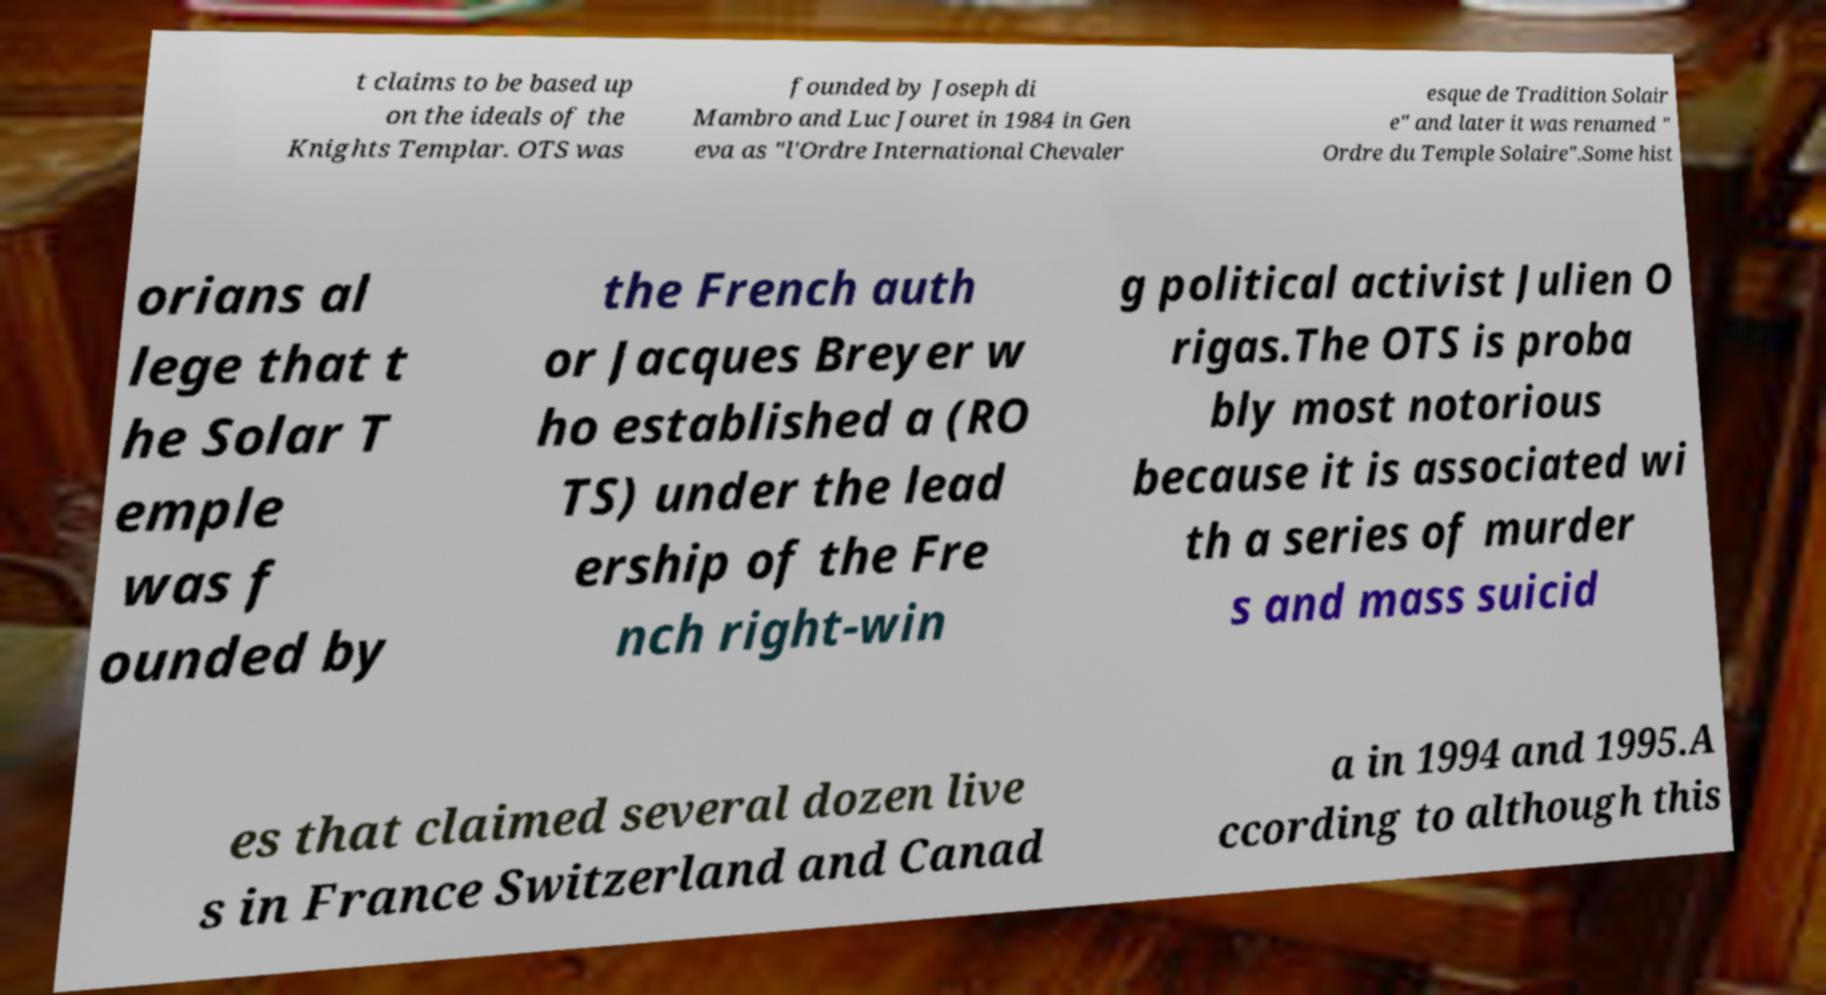Could you extract and type out the text from this image? t claims to be based up on the ideals of the Knights Templar. OTS was founded by Joseph di Mambro and Luc Jouret in 1984 in Gen eva as "l'Ordre International Chevaler esque de Tradition Solair e" and later it was renamed " Ordre du Temple Solaire".Some hist orians al lege that t he Solar T emple was f ounded by the French auth or Jacques Breyer w ho established a (RO TS) under the lead ership of the Fre nch right-win g political activist Julien O rigas.The OTS is proba bly most notorious because it is associated wi th a series of murder s and mass suicid es that claimed several dozen live s in France Switzerland and Canad a in 1994 and 1995.A ccording to although this 